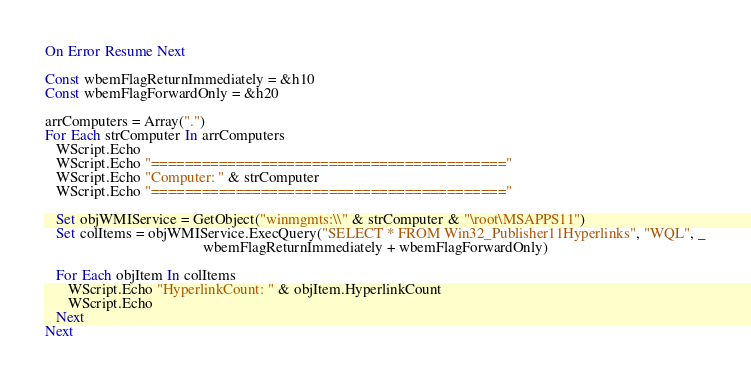<code> <loc_0><loc_0><loc_500><loc_500><_VisualBasic_>On Error Resume Next

Const wbemFlagReturnImmediately = &h10
Const wbemFlagForwardOnly = &h20

arrComputers = Array(".")
For Each strComputer In arrComputers
   WScript.Echo
   WScript.Echo "=========================================="
   WScript.Echo "Computer: " & strComputer
   WScript.Echo "=========================================="

   Set objWMIService = GetObject("winmgmts:\\" & strComputer & "\root\MSAPPS11")
   Set colItems = objWMIService.ExecQuery("SELECT * FROM Win32_Publisher11Hyperlinks", "WQL", _
                                          wbemFlagReturnImmediately + wbemFlagForwardOnly)

   For Each objItem In colItems
      WScript.Echo "HyperlinkCount: " & objItem.HyperlinkCount
      WScript.Echo
   Next
Next

</code> 